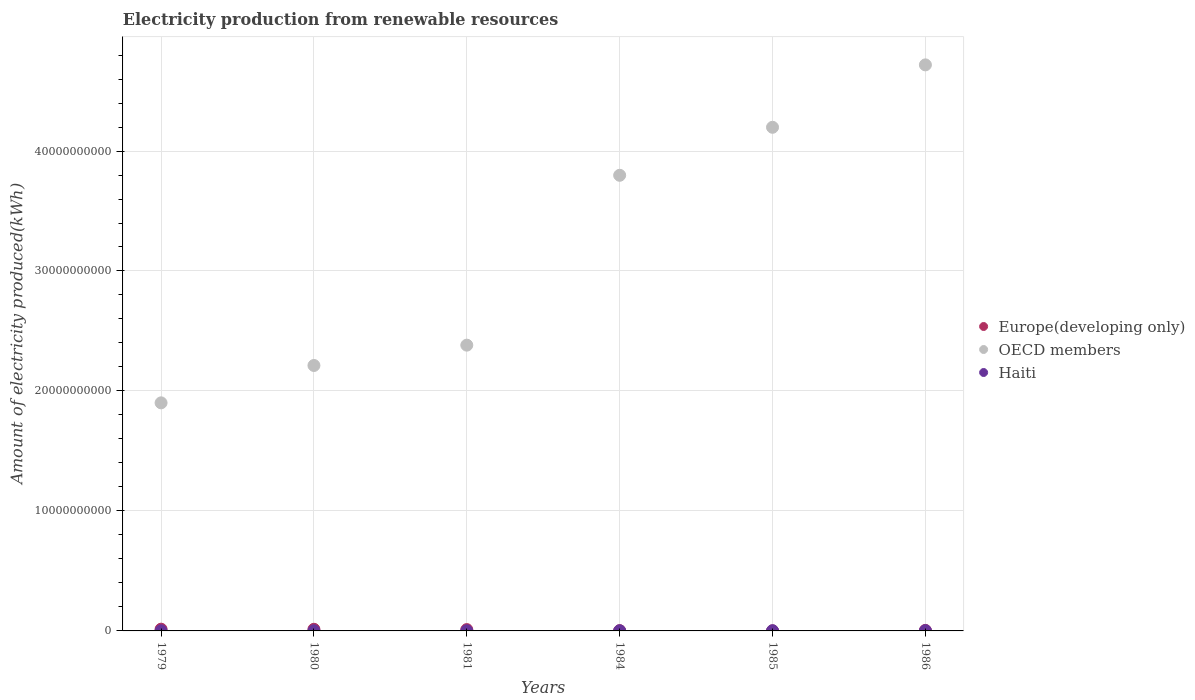How many different coloured dotlines are there?
Ensure brevity in your answer.  3. Across all years, what is the maximum amount of electricity produced in OECD members?
Your answer should be very brief. 4.72e+1. In which year was the amount of electricity produced in Haiti maximum?
Ensure brevity in your answer.  1986. What is the total amount of electricity produced in Europe(developing only) in the graph?
Provide a short and direct response. 4.63e+08. What is the difference between the amount of electricity produced in OECD members in 1981 and that in 1986?
Give a very brief answer. -2.34e+1. What is the average amount of electricity produced in Europe(developing only) per year?
Keep it short and to the point. 7.72e+07. In the year 1980, what is the difference between the amount of electricity produced in Haiti and amount of electricity produced in OECD members?
Offer a very short reply. -2.21e+1. In how many years, is the amount of electricity produced in Haiti greater than 42000000000 kWh?
Offer a terse response. 0. What is the ratio of the amount of electricity produced in Europe(developing only) in 1979 to that in 1981?
Make the answer very short. 1.32. Is the amount of electricity produced in OECD members in 1979 less than that in 1981?
Keep it short and to the point. Yes. Is the difference between the amount of electricity produced in Haiti in 1979 and 1981 greater than the difference between the amount of electricity produced in OECD members in 1979 and 1981?
Provide a succinct answer. Yes. What is the difference between the highest and the lowest amount of electricity produced in OECD members?
Your answer should be very brief. 2.82e+1. Is the sum of the amount of electricity produced in Haiti in 1981 and 1984 greater than the maximum amount of electricity produced in OECD members across all years?
Offer a very short reply. No. What is the difference between two consecutive major ticks on the Y-axis?
Your response must be concise. 1.00e+1. Does the graph contain grids?
Make the answer very short. Yes. Where does the legend appear in the graph?
Give a very brief answer. Center right. How many legend labels are there?
Provide a short and direct response. 3. What is the title of the graph?
Your answer should be compact. Electricity production from renewable resources. Does "Guinea-Bissau" appear as one of the legend labels in the graph?
Your answer should be compact. No. What is the label or title of the X-axis?
Your response must be concise. Years. What is the label or title of the Y-axis?
Your response must be concise. Amount of electricity produced(kWh). What is the Amount of electricity produced(kWh) in Europe(developing only) in 1979?
Your answer should be very brief. 1.45e+08. What is the Amount of electricity produced(kWh) in OECD members in 1979?
Ensure brevity in your answer.  1.90e+1. What is the Amount of electricity produced(kWh) of Haiti in 1979?
Provide a succinct answer. 1.20e+07. What is the Amount of electricity produced(kWh) in Europe(developing only) in 1980?
Keep it short and to the point. 1.36e+08. What is the Amount of electricity produced(kWh) of OECD members in 1980?
Your answer should be very brief. 2.21e+1. What is the Amount of electricity produced(kWh) in Europe(developing only) in 1981?
Your answer should be compact. 1.10e+08. What is the Amount of electricity produced(kWh) in OECD members in 1981?
Your answer should be compact. 2.38e+1. What is the Amount of electricity produced(kWh) in Europe(developing only) in 1984?
Your response must be concise. 2.20e+07. What is the Amount of electricity produced(kWh) of OECD members in 1984?
Make the answer very short. 3.80e+1. What is the Amount of electricity produced(kWh) of Haiti in 1984?
Provide a short and direct response. 1.20e+07. What is the Amount of electricity produced(kWh) of Europe(developing only) in 1985?
Give a very brief answer. 6.00e+06. What is the Amount of electricity produced(kWh) of OECD members in 1985?
Offer a terse response. 4.20e+1. What is the Amount of electricity produced(kWh) of Haiti in 1985?
Provide a short and direct response. 1.50e+07. What is the Amount of electricity produced(kWh) of Europe(developing only) in 1986?
Keep it short and to the point. 4.40e+07. What is the Amount of electricity produced(kWh) of OECD members in 1986?
Your answer should be very brief. 4.72e+1. What is the Amount of electricity produced(kWh) in Haiti in 1986?
Ensure brevity in your answer.  2.00e+07. Across all years, what is the maximum Amount of electricity produced(kWh) in Europe(developing only)?
Offer a terse response. 1.45e+08. Across all years, what is the maximum Amount of electricity produced(kWh) of OECD members?
Offer a very short reply. 4.72e+1. Across all years, what is the maximum Amount of electricity produced(kWh) of Haiti?
Provide a succinct answer. 2.00e+07. Across all years, what is the minimum Amount of electricity produced(kWh) in OECD members?
Provide a short and direct response. 1.90e+1. What is the total Amount of electricity produced(kWh) of Europe(developing only) in the graph?
Give a very brief answer. 4.63e+08. What is the total Amount of electricity produced(kWh) in OECD members in the graph?
Ensure brevity in your answer.  1.92e+11. What is the total Amount of electricity produced(kWh) in Haiti in the graph?
Your answer should be compact. 8.30e+07. What is the difference between the Amount of electricity produced(kWh) in Europe(developing only) in 1979 and that in 1980?
Provide a short and direct response. 9.00e+06. What is the difference between the Amount of electricity produced(kWh) in OECD members in 1979 and that in 1980?
Offer a terse response. -3.12e+09. What is the difference between the Amount of electricity produced(kWh) of Europe(developing only) in 1979 and that in 1981?
Your answer should be very brief. 3.50e+07. What is the difference between the Amount of electricity produced(kWh) in OECD members in 1979 and that in 1981?
Your answer should be very brief. -4.81e+09. What is the difference between the Amount of electricity produced(kWh) in Haiti in 1979 and that in 1981?
Ensure brevity in your answer.  0. What is the difference between the Amount of electricity produced(kWh) of Europe(developing only) in 1979 and that in 1984?
Offer a very short reply. 1.23e+08. What is the difference between the Amount of electricity produced(kWh) of OECD members in 1979 and that in 1984?
Your answer should be compact. -1.90e+1. What is the difference between the Amount of electricity produced(kWh) in Haiti in 1979 and that in 1984?
Make the answer very short. 0. What is the difference between the Amount of electricity produced(kWh) of Europe(developing only) in 1979 and that in 1985?
Offer a very short reply. 1.39e+08. What is the difference between the Amount of electricity produced(kWh) of OECD members in 1979 and that in 1985?
Your answer should be compact. -2.30e+1. What is the difference between the Amount of electricity produced(kWh) in Haiti in 1979 and that in 1985?
Ensure brevity in your answer.  -3.00e+06. What is the difference between the Amount of electricity produced(kWh) of Europe(developing only) in 1979 and that in 1986?
Provide a short and direct response. 1.01e+08. What is the difference between the Amount of electricity produced(kWh) in OECD members in 1979 and that in 1986?
Offer a very short reply. -2.82e+1. What is the difference between the Amount of electricity produced(kWh) in Haiti in 1979 and that in 1986?
Your answer should be very brief. -8.00e+06. What is the difference between the Amount of electricity produced(kWh) in Europe(developing only) in 1980 and that in 1981?
Offer a terse response. 2.60e+07. What is the difference between the Amount of electricity produced(kWh) in OECD members in 1980 and that in 1981?
Keep it short and to the point. -1.69e+09. What is the difference between the Amount of electricity produced(kWh) of Haiti in 1980 and that in 1981?
Offer a terse response. 0. What is the difference between the Amount of electricity produced(kWh) of Europe(developing only) in 1980 and that in 1984?
Keep it short and to the point. 1.14e+08. What is the difference between the Amount of electricity produced(kWh) in OECD members in 1980 and that in 1984?
Offer a very short reply. -1.59e+1. What is the difference between the Amount of electricity produced(kWh) of Europe(developing only) in 1980 and that in 1985?
Your answer should be very brief. 1.30e+08. What is the difference between the Amount of electricity produced(kWh) of OECD members in 1980 and that in 1985?
Provide a short and direct response. -1.99e+1. What is the difference between the Amount of electricity produced(kWh) in Haiti in 1980 and that in 1985?
Your response must be concise. -3.00e+06. What is the difference between the Amount of electricity produced(kWh) in Europe(developing only) in 1980 and that in 1986?
Offer a terse response. 9.20e+07. What is the difference between the Amount of electricity produced(kWh) in OECD members in 1980 and that in 1986?
Make the answer very short. -2.51e+1. What is the difference between the Amount of electricity produced(kWh) in Haiti in 1980 and that in 1986?
Your answer should be very brief. -8.00e+06. What is the difference between the Amount of electricity produced(kWh) in Europe(developing only) in 1981 and that in 1984?
Offer a terse response. 8.80e+07. What is the difference between the Amount of electricity produced(kWh) in OECD members in 1981 and that in 1984?
Your answer should be compact. -1.42e+1. What is the difference between the Amount of electricity produced(kWh) of Haiti in 1981 and that in 1984?
Give a very brief answer. 0. What is the difference between the Amount of electricity produced(kWh) of Europe(developing only) in 1981 and that in 1985?
Provide a succinct answer. 1.04e+08. What is the difference between the Amount of electricity produced(kWh) of OECD members in 1981 and that in 1985?
Keep it short and to the point. -1.82e+1. What is the difference between the Amount of electricity produced(kWh) in Europe(developing only) in 1981 and that in 1986?
Offer a terse response. 6.60e+07. What is the difference between the Amount of electricity produced(kWh) of OECD members in 1981 and that in 1986?
Offer a terse response. -2.34e+1. What is the difference between the Amount of electricity produced(kWh) in Haiti in 1981 and that in 1986?
Provide a succinct answer. -8.00e+06. What is the difference between the Amount of electricity produced(kWh) of Europe(developing only) in 1984 and that in 1985?
Your answer should be compact. 1.60e+07. What is the difference between the Amount of electricity produced(kWh) in OECD members in 1984 and that in 1985?
Your answer should be compact. -4.00e+09. What is the difference between the Amount of electricity produced(kWh) of Europe(developing only) in 1984 and that in 1986?
Provide a short and direct response. -2.20e+07. What is the difference between the Amount of electricity produced(kWh) of OECD members in 1984 and that in 1986?
Your response must be concise. -9.20e+09. What is the difference between the Amount of electricity produced(kWh) in Haiti in 1984 and that in 1986?
Make the answer very short. -8.00e+06. What is the difference between the Amount of electricity produced(kWh) of Europe(developing only) in 1985 and that in 1986?
Offer a very short reply. -3.80e+07. What is the difference between the Amount of electricity produced(kWh) of OECD members in 1985 and that in 1986?
Offer a very short reply. -5.20e+09. What is the difference between the Amount of electricity produced(kWh) in Haiti in 1985 and that in 1986?
Your answer should be compact. -5.00e+06. What is the difference between the Amount of electricity produced(kWh) of Europe(developing only) in 1979 and the Amount of electricity produced(kWh) of OECD members in 1980?
Provide a succinct answer. -2.20e+1. What is the difference between the Amount of electricity produced(kWh) of Europe(developing only) in 1979 and the Amount of electricity produced(kWh) of Haiti in 1980?
Make the answer very short. 1.33e+08. What is the difference between the Amount of electricity produced(kWh) of OECD members in 1979 and the Amount of electricity produced(kWh) of Haiti in 1980?
Offer a terse response. 1.90e+1. What is the difference between the Amount of electricity produced(kWh) in Europe(developing only) in 1979 and the Amount of electricity produced(kWh) in OECD members in 1981?
Your response must be concise. -2.37e+1. What is the difference between the Amount of electricity produced(kWh) in Europe(developing only) in 1979 and the Amount of electricity produced(kWh) in Haiti in 1981?
Keep it short and to the point. 1.33e+08. What is the difference between the Amount of electricity produced(kWh) in OECD members in 1979 and the Amount of electricity produced(kWh) in Haiti in 1981?
Keep it short and to the point. 1.90e+1. What is the difference between the Amount of electricity produced(kWh) in Europe(developing only) in 1979 and the Amount of electricity produced(kWh) in OECD members in 1984?
Ensure brevity in your answer.  -3.78e+1. What is the difference between the Amount of electricity produced(kWh) of Europe(developing only) in 1979 and the Amount of electricity produced(kWh) of Haiti in 1984?
Your answer should be very brief. 1.33e+08. What is the difference between the Amount of electricity produced(kWh) in OECD members in 1979 and the Amount of electricity produced(kWh) in Haiti in 1984?
Provide a short and direct response. 1.90e+1. What is the difference between the Amount of electricity produced(kWh) of Europe(developing only) in 1979 and the Amount of electricity produced(kWh) of OECD members in 1985?
Offer a terse response. -4.18e+1. What is the difference between the Amount of electricity produced(kWh) in Europe(developing only) in 1979 and the Amount of electricity produced(kWh) in Haiti in 1985?
Provide a short and direct response. 1.30e+08. What is the difference between the Amount of electricity produced(kWh) of OECD members in 1979 and the Amount of electricity produced(kWh) of Haiti in 1985?
Offer a very short reply. 1.90e+1. What is the difference between the Amount of electricity produced(kWh) in Europe(developing only) in 1979 and the Amount of electricity produced(kWh) in OECD members in 1986?
Ensure brevity in your answer.  -4.70e+1. What is the difference between the Amount of electricity produced(kWh) of Europe(developing only) in 1979 and the Amount of electricity produced(kWh) of Haiti in 1986?
Keep it short and to the point. 1.25e+08. What is the difference between the Amount of electricity produced(kWh) of OECD members in 1979 and the Amount of electricity produced(kWh) of Haiti in 1986?
Make the answer very short. 1.90e+1. What is the difference between the Amount of electricity produced(kWh) in Europe(developing only) in 1980 and the Amount of electricity produced(kWh) in OECD members in 1981?
Your answer should be very brief. -2.37e+1. What is the difference between the Amount of electricity produced(kWh) of Europe(developing only) in 1980 and the Amount of electricity produced(kWh) of Haiti in 1981?
Give a very brief answer. 1.24e+08. What is the difference between the Amount of electricity produced(kWh) of OECD members in 1980 and the Amount of electricity produced(kWh) of Haiti in 1981?
Ensure brevity in your answer.  2.21e+1. What is the difference between the Amount of electricity produced(kWh) in Europe(developing only) in 1980 and the Amount of electricity produced(kWh) in OECD members in 1984?
Your response must be concise. -3.78e+1. What is the difference between the Amount of electricity produced(kWh) of Europe(developing only) in 1980 and the Amount of electricity produced(kWh) of Haiti in 1984?
Provide a succinct answer. 1.24e+08. What is the difference between the Amount of electricity produced(kWh) of OECD members in 1980 and the Amount of electricity produced(kWh) of Haiti in 1984?
Your answer should be very brief. 2.21e+1. What is the difference between the Amount of electricity produced(kWh) in Europe(developing only) in 1980 and the Amount of electricity produced(kWh) in OECD members in 1985?
Provide a short and direct response. -4.18e+1. What is the difference between the Amount of electricity produced(kWh) in Europe(developing only) in 1980 and the Amount of electricity produced(kWh) in Haiti in 1985?
Keep it short and to the point. 1.21e+08. What is the difference between the Amount of electricity produced(kWh) of OECD members in 1980 and the Amount of electricity produced(kWh) of Haiti in 1985?
Provide a short and direct response. 2.21e+1. What is the difference between the Amount of electricity produced(kWh) in Europe(developing only) in 1980 and the Amount of electricity produced(kWh) in OECD members in 1986?
Your answer should be compact. -4.70e+1. What is the difference between the Amount of electricity produced(kWh) in Europe(developing only) in 1980 and the Amount of electricity produced(kWh) in Haiti in 1986?
Make the answer very short. 1.16e+08. What is the difference between the Amount of electricity produced(kWh) of OECD members in 1980 and the Amount of electricity produced(kWh) of Haiti in 1986?
Offer a very short reply. 2.21e+1. What is the difference between the Amount of electricity produced(kWh) of Europe(developing only) in 1981 and the Amount of electricity produced(kWh) of OECD members in 1984?
Offer a very short reply. -3.79e+1. What is the difference between the Amount of electricity produced(kWh) of Europe(developing only) in 1981 and the Amount of electricity produced(kWh) of Haiti in 1984?
Ensure brevity in your answer.  9.80e+07. What is the difference between the Amount of electricity produced(kWh) in OECD members in 1981 and the Amount of electricity produced(kWh) in Haiti in 1984?
Provide a short and direct response. 2.38e+1. What is the difference between the Amount of electricity produced(kWh) of Europe(developing only) in 1981 and the Amount of electricity produced(kWh) of OECD members in 1985?
Keep it short and to the point. -4.19e+1. What is the difference between the Amount of electricity produced(kWh) of Europe(developing only) in 1981 and the Amount of electricity produced(kWh) of Haiti in 1985?
Keep it short and to the point. 9.50e+07. What is the difference between the Amount of electricity produced(kWh) of OECD members in 1981 and the Amount of electricity produced(kWh) of Haiti in 1985?
Offer a very short reply. 2.38e+1. What is the difference between the Amount of electricity produced(kWh) of Europe(developing only) in 1981 and the Amount of electricity produced(kWh) of OECD members in 1986?
Make the answer very short. -4.71e+1. What is the difference between the Amount of electricity produced(kWh) of Europe(developing only) in 1981 and the Amount of electricity produced(kWh) of Haiti in 1986?
Your answer should be very brief. 9.00e+07. What is the difference between the Amount of electricity produced(kWh) of OECD members in 1981 and the Amount of electricity produced(kWh) of Haiti in 1986?
Your response must be concise. 2.38e+1. What is the difference between the Amount of electricity produced(kWh) of Europe(developing only) in 1984 and the Amount of electricity produced(kWh) of OECD members in 1985?
Your answer should be compact. -4.20e+1. What is the difference between the Amount of electricity produced(kWh) in Europe(developing only) in 1984 and the Amount of electricity produced(kWh) in Haiti in 1985?
Your response must be concise. 7.00e+06. What is the difference between the Amount of electricity produced(kWh) in OECD members in 1984 and the Amount of electricity produced(kWh) in Haiti in 1985?
Your answer should be compact. 3.80e+1. What is the difference between the Amount of electricity produced(kWh) of Europe(developing only) in 1984 and the Amount of electricity produced(kWh) of OECD members in 1986?
Your answer should be very brief. -4.72e+1. What is the difference between the Amount of electricity produced(kWh) of OECD members in 1984 and the Amount of electricity produced(kWh) of Haiti in 1986?
Give a very brief answer. 3.80e+1. What is the difference between the Amount of electricity produced(kWh) of Europe(developing only) in 1985 and the Amount of electricity produced(kWh) of OECD members in 1986?
Provide a succinct answer. -4.72e+1. What is the difference between the Amount of electricity produced(kWh) of Europe(developing only) in 1985 and the Amount of electricity produced(kWh) of Haiti in 1986?
Keep it short and to the point. -1.40e+07. What is the difference between the Amount of electricity produced(kWh) of OECD members in 1985 and the Amount of electricity produced(kWh) of Haiti in 1986?
Your answer should be very brief. 4.20e+1. What is the average Amount of electricity produced(kWh) in Europe(developing only) per year?
Your answer should be very brief. 7.72e+07. What is the average Amount of electricity produced(kWh) of OECD members per year?
Keep it short and to the point. 3.20e+1. What is the average Amount of electricity produced(kWh) in Haiti per year?
Ensure brevity in your answer.  1.38e+07. In the year 1979, what is the difference between the Amount of electricity produced(kWh) of Europe(developing only) and Amount of electricity produced(kWh) of OECD members?
Give a very brief answer. -1.89e+1. In the year 1979, what is the difference between the Amount of electricity produced(kWh) in Europe(developing only) and Amount of electricity produced(kWh) in Haiti?
Your answer should be compact. 1.33e+08. In the year 1979, what is the difference between the Amount of electricity produced(kWh) of OECD members and Amount of electricity produced(kWh) of Haiti?
Your answer should be very brief. 1.90e+1. In the year 1980, what is the difference between the Amount of electricity produced(kWh) in Europe(developing only) and Amount of electricity produced(kWh) in OECD members?
Give a very brief answer. -2.20e+1. In the year 1980, what is the difference between the Amount of electricity produced(kWh) of Europe(developing only) and Amount of electricity produced(kWh) of Haiti?
Your response must be concise. 1.24e+08. In the year 1980, what is the difference between the Amount of electricity produced(kWh) in OECD members and Amount of electricity produced(kWh) in Haiti?
Your response must be concise. 2.21e+1. In the year 1981, what is the difference between the Amount of electricity produced(kWh) of Europe(developing only) and Amount of electricity produced(kWh) of OECD members?
Your answer should be very brief. -2.37e+1. In the year 1981, what is the difference between the Amount of electricity produced(kWh) in Europe(developing only) and Amount of electricity produced(kWh) in Haiti?
Your answer should be very brief. 9.80e+07. In the year 1981, what is the difference between the Amount of electricity produced(kWh) of OECD members and Amount of electricity produced(kWh) of Haiti?
Provide a succinct answer. 2.38e+1. In the year 1984, what is the difference between the Amount of electricity produced(kWh) in Europe(developing only) and Amount of electricity produced(kWh) in OECD members?
Your answer should be compact. -3.80e+1. In the year 1984, what is the difference between the Amount of electricity produced(kWh) of Europe(developing only) and Amount of electricity produced(kWh) of Haiti?
Provide a succinct answer. 1.00e+07. In the year 1984, what is the difference between the Amount of electricity produced(kWh) of OECD members and Amount of electricity produced(kWh) of Haiti?
Offer a very short reply. 3.80e+1. In the year 1985, what is the difference between the Amount of electricity produced(kWh) of Europe(developing only) and Amount of electricity produced(kWh) of OECD members?
Your answer should be very brief. -4.20e+1. In the year 1985, what is the difference between the Amount of electricity produced(kWh) of Europe(developing only) and Amount of electricity produced(kWh) of Haiti?
Your answer should be compact. -9.00e+06. In the year 1985, what is the difference between the Amount of electricity produced(kWh) in OECD members and Amount of electricity produced(kWh) in Haiti?
Ensure brevity in your answer.  4.20e+1. In the year 1986, what is the difference between the Amount of electricity produced(kWh) in Europe(developing only) and Amount of electricity produced(kWh) in OECD members?
Make the answer very short. -4.71e+1. In the year 1986, what is the difference between the Amount of electricity produced(kWh) of Europe(developing only) and Amount of electricity produced(kWh) of Haiti?
Your response must be concise. 2.40e+07. In the year 1986, what is the difference between the Amount of electricity produced(kWh) in OECD members and Amount of electricity produced(kWh) in Haiti?
Make the answer very short. 4.72e+1. What is the ratio of the Amount of electricity produced(kWh) in Europe(developing only) in 1979 to that in 1980?
Keep it short and to the point. 1.07. What is the ratio of the Amount of electricity produced(kWh) in OECD members in 1979 to that in 1980?
Your response must be concise. 0.86. What is the ratio of the Amount of electricity produced(kWh) in Haiti in 1979 to that in 1980?
Ensure brevity in your answer.  1. What is the ratio of the Amount of electricity produced(kWh) of Europe(developing only) in 1979 to that in 1981?
Your answer should be compact. 1.32. What is the ratio of the Amount of electricity produced(kWh) of OECD members in 1979 to that in 1981?
Your answer should be very brief. 0.8. What is the ratio of the Amount of electricity produced(kWh) in Haiti in 1979 to that in 1981?
Your answer should be compact. 1. What is the ratio of the Amount of electricity produced(kWh) of Europe(developing only) in 1979 to that in 1984?
Your answer should be compact. 6.59. What is the ratio of the Amount of electricity produced(kWh) of OECD members in 1979 to that in 1984?
Keep it short and to the point. 0.5. What is the ratio of the Amount of electricity produced(kWh) of Haiti in 1979 to that in 1984?
Give a very brief answer. 1. What is the ratio of the Amount of electricity produced(kWh) of Europe(developing only) in 1979 to that in 1985?
Your response must be concise. 24.17. What is the ratio of the Amount of electricity produced(kWh) in OECD members in 1979 to that in 1985?
Offer a terse response. 0.45. What is the ratio of the Amount of electricity produced(kWh) in Europe(developing only) in 1979 to that in 1986?
Make the answer very short. 3.3. What is the ratio of the Amount of electricity produced(kWh) in OECD members in 1979 to that in 1986?
Offer a terse response. 0.4. What is the ratio of the Amount of electricity produced(kWh) of Europe(developing only) in 1980 to that in 1981?
Ensure brevity in your answer.  1.24. What is the ratio of the Amount of electricity produced(kWh) of OECD members in 1980 to that in 1981?
Ensure brevity in your answer.  0.93. What is the ratio of the Amount of electricity produced(kWh) in Europe(developing only) in 1980 to that in 1984?
Give a very brief answer. 6.18. What is the ratio of the Amount of electricity produced(kWh) of OECD members in 1980 to that in 1984?
Keep it short and to the point. 0.58. What is the ratio of the Amount of electricity produced(kWh) in Haiti in 1980 to that in 1984?
Make the answer very short. 1. What is the ratio of the Amount of electricity produced(kWh) of Europe(developing only) in 1980 to that in 1985?
Keep it short and to the point. 22.67. What is the ratio of the Amount of electricity produced(kWh) of OECD members in 1980 to that in 1985?
Your answer should be compact. 0.53. What is the ratio of the Amount of electricity produced(kWh) of Europe(developing only) in 1980 to that in 1986?
Provide a short and direct response. 3.09. What is the ratio of the Amount of electricity produced(kWh) of OECD members in 1980 to that in 1986?
Offer a terse response. 0.47. What is the ratio of the Amount of electricity produced(kWh) in Europe(developing only) in 1981 to that in 1984?
Make the answer very short. 5. What is the ratio of the Amount of electricity produced(kWh) in OECD members in 1981 to that in 1984?
Offer a very short reply. 0.63. What is the ratio of the Amount of electricity produced(kWh) of Europe(developing only) in 1981 to that in 1985?
Make the answer very short. 18.33. What is the ratio of the Amount of electricity produced(kWh) in OECD members in 1981 to that in 1985?
Offer a very short reply. 0.57. What is the ratio of the Amount of electricity produced(kWh) in OECD members in 1981 to that in 1986?
Your answer should be very brief. 0.5. What is the ratio of the Amount of electricity produced(kWh) in Europe(developing only) in 1984 to that in 1985?
Your answer should be compact. 3.67. What is the ratio of the Amount of electricity produced(kWh) in OECD members in 1984 to that in 1985?
Your answer should be compact. 0.9. What is the ratio of the Amount of electricity produced(kWh) of OECD members in 1984 to that in 1986?
Make the answer very short. 0.8. What is the ratio of the Amount of electricity produced(kWh) of Europe(developing only) in 1985 to that in 1986?
Your response must be concise. 0.14. What is the ratio of the Amount of electricity produced(kWh) in OECD members in 1985 to that in 1986?
Your answer should be compact. 0.89. What is the ratio of the Amount of electricity produced(kWh) of Haiti in 1985 to that in 1986?
Your answer should be compact. 0.75. What is the difference between the highest and the second highest Amount of electricity produced(kWh) in Europe(developing only)?
Provide a succinct answer. 9.00e+06. What is the difference between the highest and the second highest Amount of electricity produced(kWh) of OECD members?
Your answer should be compact. 5.20e+09. What is the difference between the highest and the lowest Amount of electricity produced(kWh) of Europe(developing only)?
Make the answer very short. 1.39e+08. What is the difference between the highest and the lowest Amount of electricity produced(kWh) in OECD members?
Ensure brevity in your answer.  2.82e+1. What is the difference between the highest and the lowest Amount of electricity produced(kWh) of Haiti?
Provide a short and direct response. 8.00e+06. 